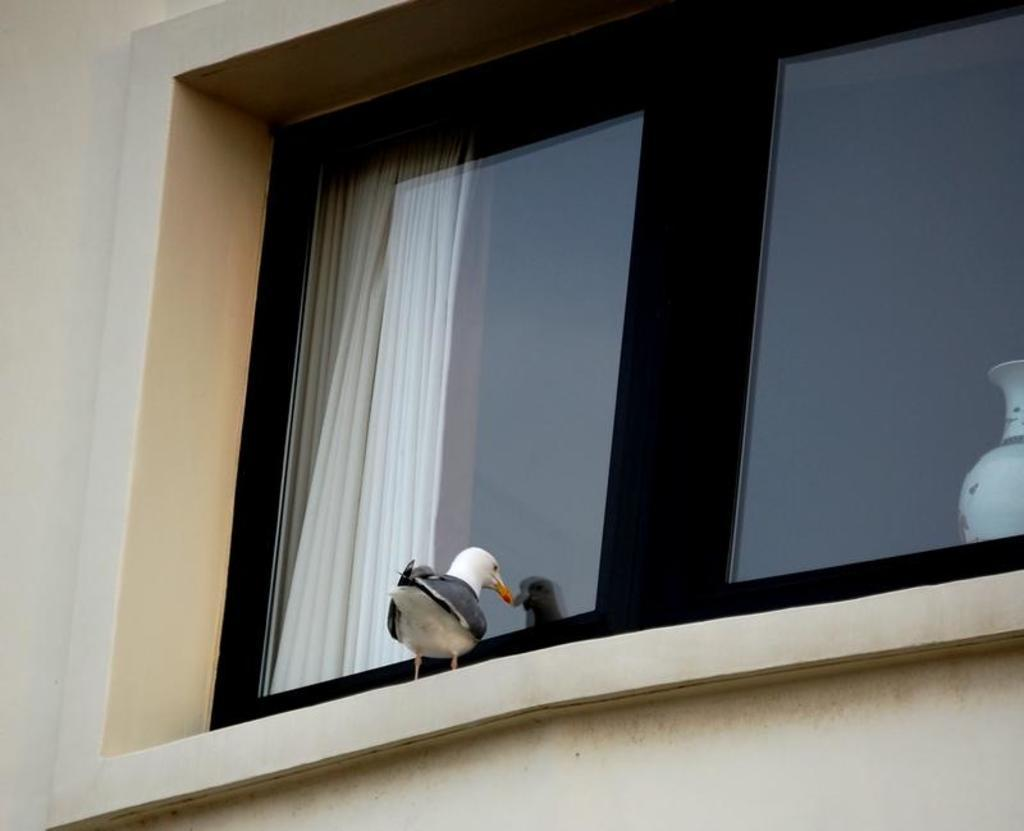What type of animal can be seen in the image? There is a bird in the image. Where is the bird located in relation to other objects? The bird is standing near a window. What is on the left side of the image? There is a wall on the left side of the image. What is on the right side of the image? There is a pot on the right side of the image. What type of work is the bird doing in the image? The bird is not shown doing any work in the image; it is simply standing near a window. How many pigs are visible in the image? There are no pigs present in the image. 